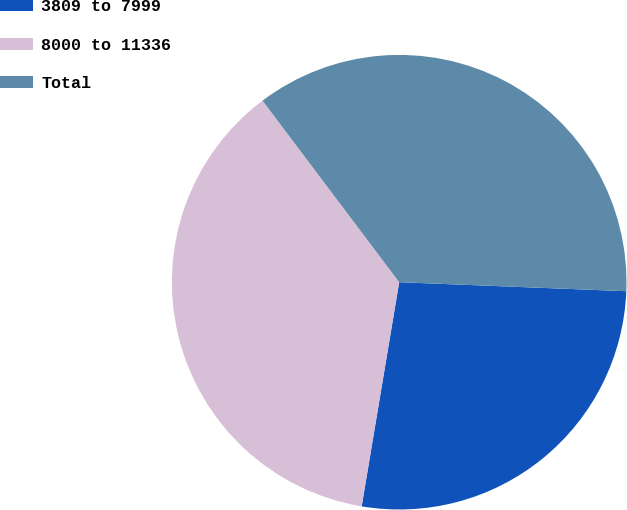Convert chart. <chart><loc_0><loc_0><loc_500><loc_500><pie_chart><fcel>3809 to 7999<fcel>8000 to 11336<fcel>Total<nl><fcel>27.01%<fcel>37.09%<fcel>35.9%<nl></chart> 